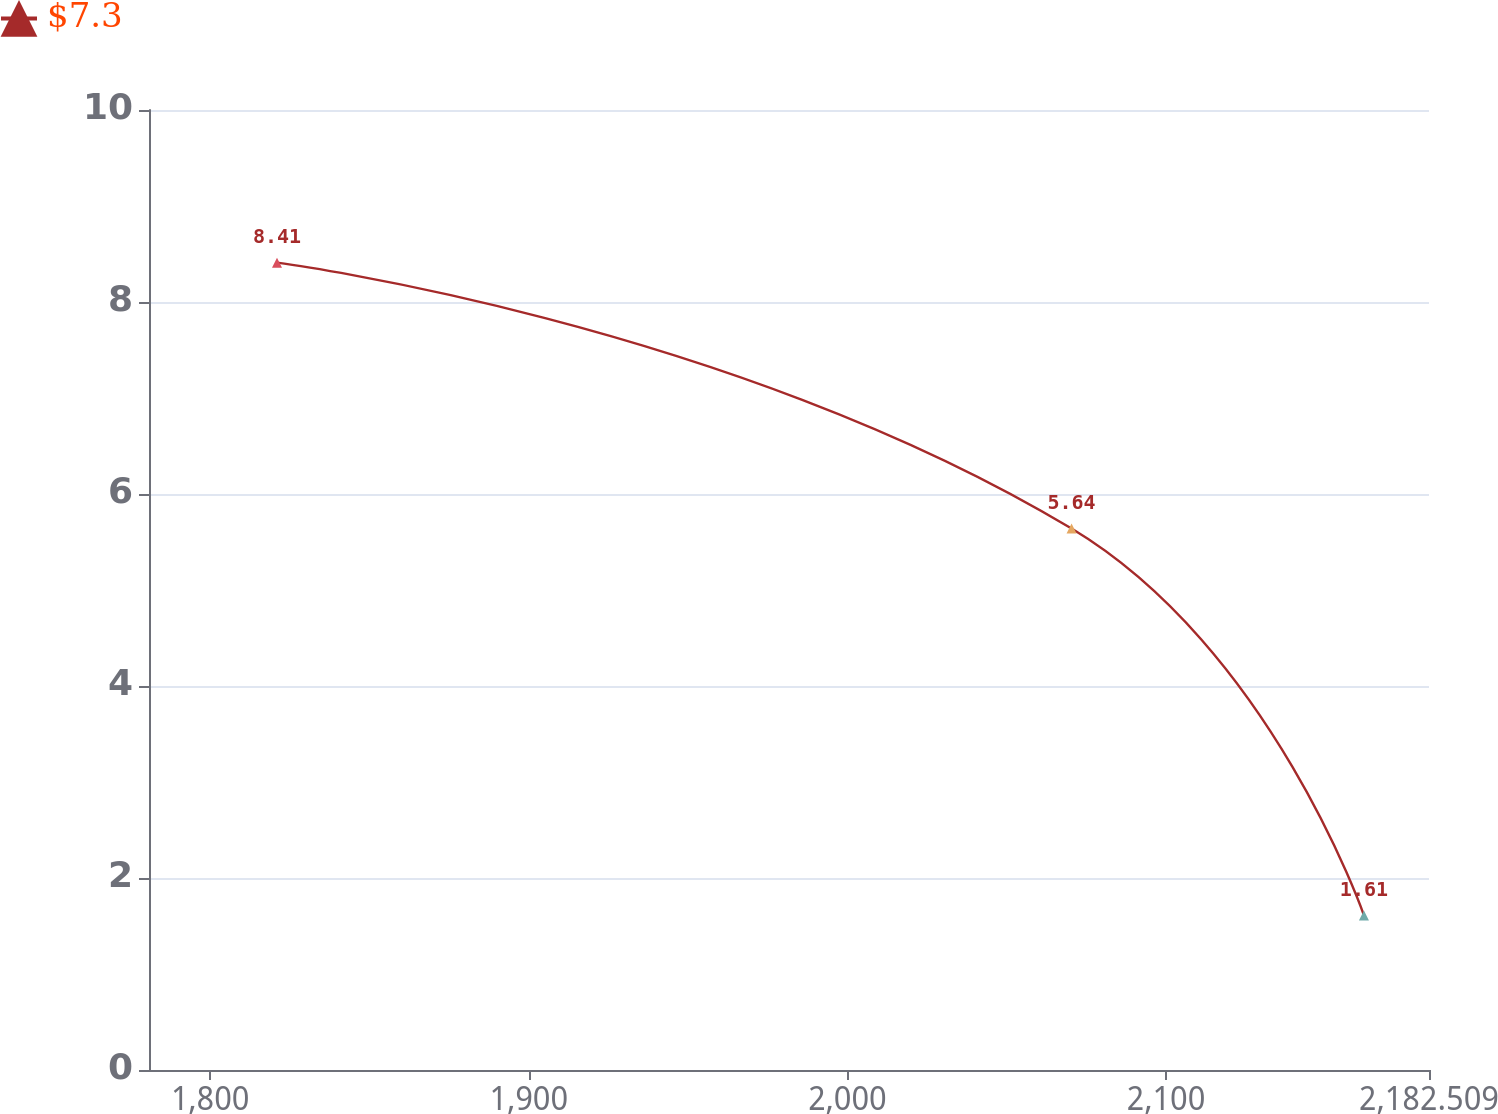<chart> <loc_0><loc_0><loc_500><loc_500><line_chart><ecel><fcel>$7.3<nl><fcel>1820.97<fcel>8.41<nl><fcel>2070.33<fcel>5.64<nl><fcel>2162.09<fcel>1.61<nl><fcel>2222.68<fcel>0.85<nl></chart> 